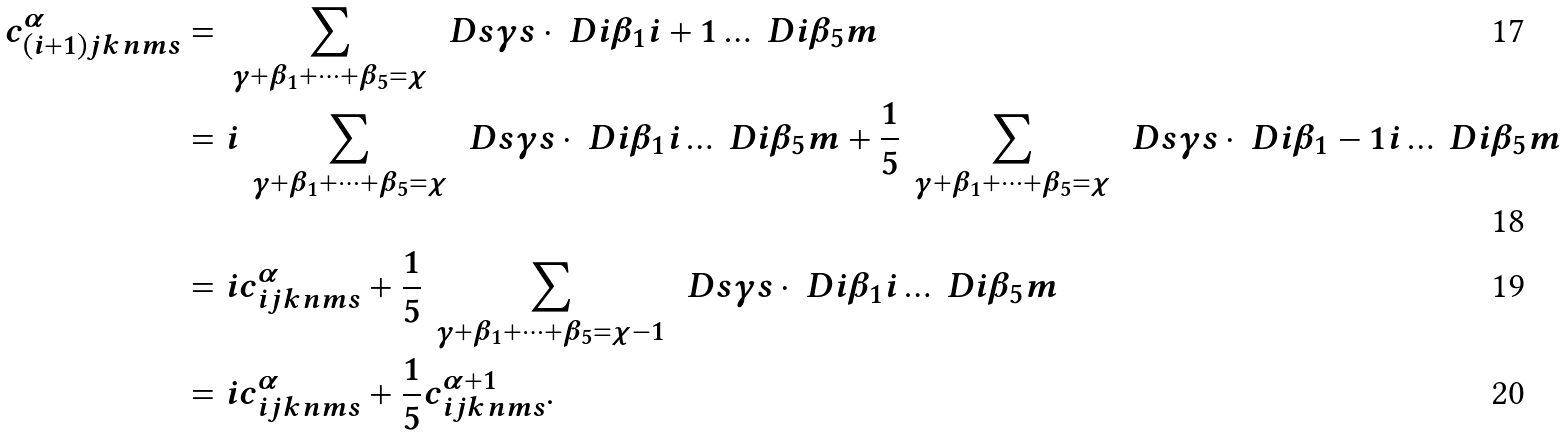Convert formula to latex. <formula><loc_0><loc_0><loc_500><loc_500>c ^ { \alpha } _ { ( i + 1 ) j k n m s } & = \, \sum _ { \gamma + \beta _ { 1 } + \dots + \beta _ { 5 } = \chi } \, \ D s { \gamma } { s } \cdot \ D i { \beta _ { 1 } } { i + 1 } \dots \ D i { \beta _ { 5 } } { m } \\ & = i \, \sum _ { \gamma + \beta _ { 1 } + \dots + \beta _ { 5 } = \chi } \, \ D s { \gamma } { s } \cdot \ D i { \beta _ { 1 } } { i } \dots \ D i { \beta _ { 5 } } { m } + \frac { 1 } { 5 } \, \sum _ { \gamma + \beta _ { 1 } + \dots + \beta _ { 5 } = \chi } \, \ D s { \gamma } { s } \cdot \ D i { \beta _ { 1 } - 1 } { i } \dots \ D i { \beta _ { 5 } } { m } \\ & = i c ^ { \alpha } _ { i j k n m s } + \frac { 1 } { 5 } \, \sum _ { \gamma + \beta _ { 1 } + \dots + \beta _ { 5 } = \chi - 1 } \, \ D s { \gamma } { s } \cdot \ D i { \beta _ { 1 } } { i } \dots \ D i { \beta _ { 5 } } { m } \\ & = i c ^ { \alpha } _ { i j k n m s } + \frac { 1 } { 5 } c ^ { \alpha + 1 } _ { i j k n m s } .</formula> 